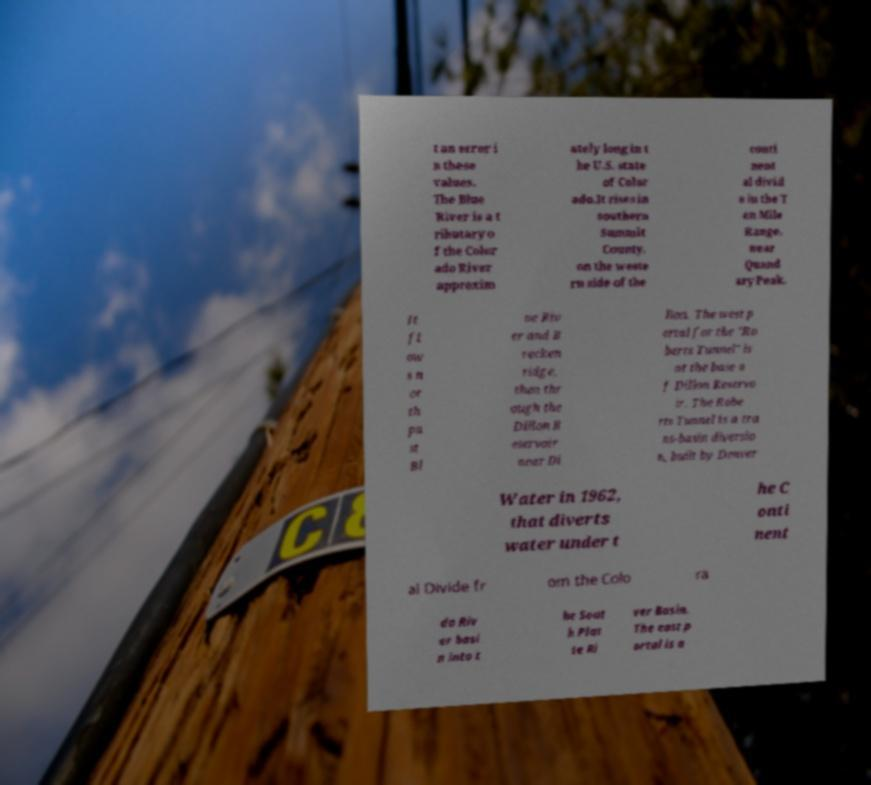There's text embedded in this image that I need extracted. Can you transcribe it verbatim? t an error i n these values. The Blue River is a t ributary o f the Color ado River approxim ately long in t he U.S. state of Color ado.It rises in southern Summit County, on the weste rn side of the conti nent al divid e in the T en Mile Range, near Quand ary Peak. It fl ow s n or th pa st Bl ue Riv er and B recken ridge, then thr ough the Dillon R eservoir near Di llon. The west p ortal for the "Ro berts Tunnel" is at the base o f Dillon Reservo ir. The Robe rts Tunnel is a tra ns-basin diversio n, built by Denver Water in 1962, that diverts water under t he C onti nent al Divide fr om the Colo ra do Riv er basi n into t he Sout h Plat te Ri ver Basin. The east p ortal is a 